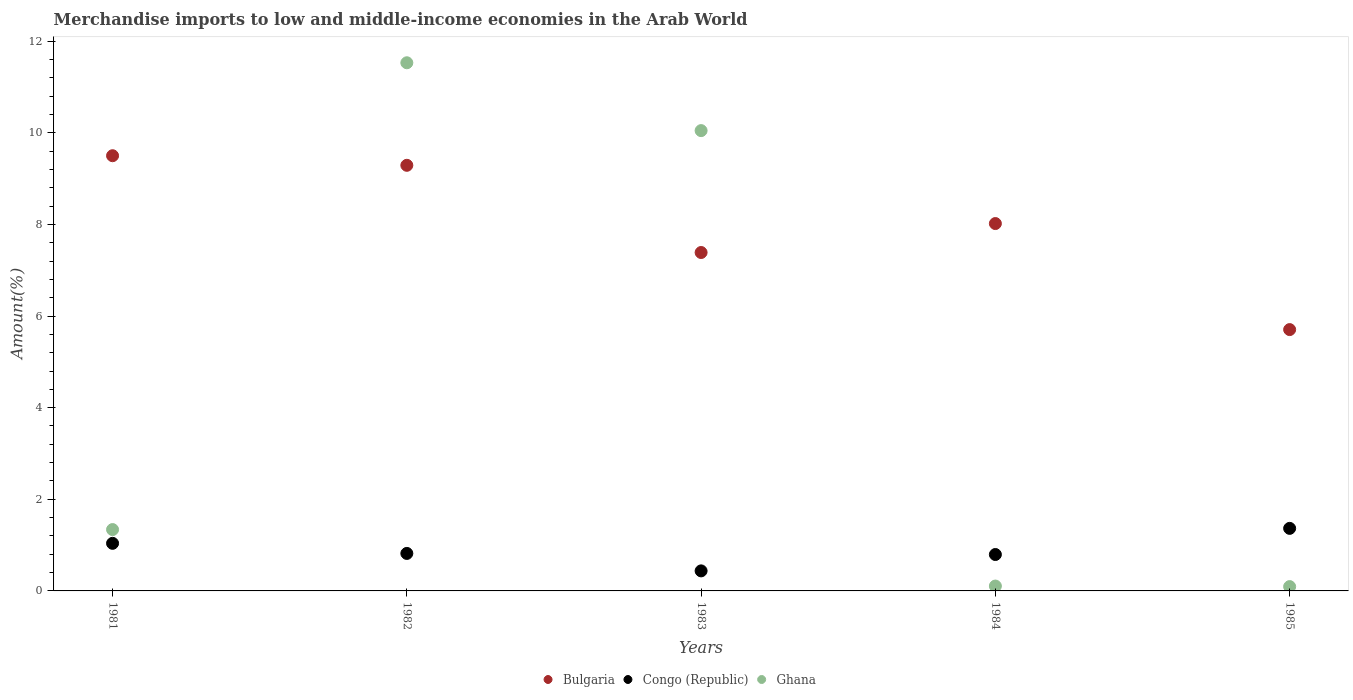How many different coloured dotlines are there?
Your response must be concise. 3. What is the percentage of amount earned from merchandise imports in Ghana in 1981?
Provide a succinct answer. 1.34. Across all years, what is the maximum percentage of amount earned from merchandise imports in Congo (Republic)?
Keep it short and to the point. 1.37. Across all years, what is the minimum percentage of amount earned from merchandise imports in Ghana?
Offer a very short reply. 0.09. In which year was the percentage of amount earned from merchandise imports in Bulgaria maximum?
Ensure brevity in your answer.  1981. In which year was the percentage of amount earned from merchandise imports in Ghana minimum?
Your answer should be very brief. 1985. What is the total percentage of amount earned from merchandise imports in Ghana in the graph?
Your response must be concise. 23.12. What is the difference between the percentage of amount earned from merchandise imports in Bulgaria in 1983 and that in 1984?
Ensure brevity in your answer.  -0.63. What is the difference between the percentage of amount earned from merchandise imports in Ghana in 1984 and the percentage of amount earned from merchandise imports in Bulgaria in 1981?
Ensure brevity in your answer.  -9.39. What is the average percentage of amount earned from merchandise imports in Ghana per year?
Keep it short and to the point. 4.62. In the year 1983, what is the difference between the percentage of amount earned from merchandise imports in Ghana and percentage of amount earned from merchandise imports in Bulgaria?
Make the answer very short. 2.66. In how many years, is the percentage of amount earned from merchandise imports in Congo (Republic) greater than 7.6 %?
Your response must be concise. 0. What is the ratio of the percentage of amount earned from merchandise imports in Congo (Republic) in 1982 to that in 1983?
Provide a short and direct response. 1.87. Is the percentage of amount earned from merchandise imports in Bulgaria in 1982 less than that in 1983?
Make the answer very short. No. What is the difference between the highest and the second highest percentage of amount earned from merchandise imports in Bulgaria?
Provide a succinct answer. 0.21. What is the difference between the highest and the lowest percentage of amount earned from merchandise imports in Ghana?
Ensure brevity in your answer.  11.43. Is the sum of the percentage of amount earned from merchandise imports in Bulgaria in 1981 and 1983 greater than the maximum percentage of amount earned from merchandise imports in Congo (Republic) across all years?
Your answer should be compact. Yes. Is the percentage of amount earned from merchandise imports in Bulgaria strictly greater than the percentage of amount earned from merchandise imports in Congo (Republic) over the years?
Make the answer very short. Yes. Is the percentage of amount earned from merchandise imports in Ghana strictly less than the percentage of amount earned from merchandise imports in Bulgaria over the years?
Your answer should be compact. No. How many years are there in the graph?
Keep it short and to the point. 5. Does the graph contain any zero values?
Make the answer very short. No. Does the graph contain grids?
Make the answer very short. No. How many legend labels are there?
Give a very brief answer. 3. How are the legend labels stacked?
Offer a very short reply. Horizontal. What is the title of the graph?
Provide a short and direct response. Merchandise imports to low and middle-income economies in the Arab World. What is the label or title of the Y-axis?
Offer a very short reply. Amount(%). What is the Amount(%) of Bulgaria in 1981?
Your answer should be very brief. 9.5. What is the Amount(%) of Congo (Republic) in 1981?
Provide a short and direct response. 1.04. What is the Amount(%) of Ghana in 1981?
Make the answer very short. 1.34. What is the Amount(%) in Bulgaria in 1982?
Make the answer very short. 9.29. What is the Amount(%) in Congo (Republic) in 1982?
Your response must be concise. 0.82. What is the Amount(%) in Ghana in 1982?
Ensure brevity in your answer.  11.53. What is the Amount(%) of Bulgaria in 1983?
Your answer should be very brief. 7.39. What is the Amount(%) in Congo (Republic) in 1983?
Offer a terse response. 0.44. What is the Amount(%) of Ghana in 1983?
Ensure brevity in your answer.  10.05. What is the Amount(%) in Bulgaria in 1984?
Your answer should be very brief. 8.02. What is the Amount(%) of Congo (Republic) in 1984?
Your answer should be compact. 0.79. What is the Amount(%) in Ghana in 1984?
Your answer should be compact. 0.11. What is the Amount(%) of Bulgaria in 1985?
Keep it short and to the point. 5.7. What is the Amount(%) of Congo (Republic) in 1985?
Provide a short and direct response. 1.37. What is the Amount(%) of Ghana in 1985?
Offer a terse response. 0.09. Across all years, what is the maximum Amount(%) of Bulgaria?
Your answer should be very brief. 9.5. Across all years, what is the maximum Amount(%) in Congo (Republic)?
Keep it short and to the point. 1.37. Across all years, what is the maximum Amount(%) in Ghana?
Your response must be concise. 11.53. Across all years, what is the minimum Amount(%) of Bulgaria?
Your answer should be very brief. 5.7. Across all years, what is the minimum Amount(%) of Congo (Republic)?
Make the answer very short. 0.44. Across all years, what is the minimum Amount(%) in Ghana?
Give a very brief answer. 0.09. What is the total Amount(%) in Bulgaria in the graph?
Your response must be concise. 39.9. What is the total Amount(%) of Congo (Republic) in the graph?
Offer a terse response. 4.46. What is the total Amount(%) of Ghana in the graph?
Make the answer very short. 23.12. What is the difference between the Amount(%) of Bulgaria in 1981 and that in 1982?
Provide a succinct answer. 0.21. What is the difference between the Amount(%) of Congo (Republic) in 1981 and that in 1982?
Give a very brief answer. 0.22. What is the difference between the Amount(%) of Ghana in 1981 and that in 1982?
Offer a very short reply. -10.19. What is the difference between the Amount(%) of Bulgaria in 1981 and that in 1983?
Keep it short and to the point. 2.11. What is the difference between the Amount(%) in Congo (Republic) in 1981 and that in 1983?
Provide a short and direct response. 0.6. What is the difference between the Amount(%) of Ghana in 1981 and that in 1983?
Provide a succinct answer. -8.71. What is the difference between the Amount(%) of Bulgaria in 1981 and that in 1984?
Keep it short and to the point. 1.48. What is the difference between the Amount(%) in Congo (Republic) in 1981 and that in 1984?
Provide a succinct answer. 0.24. What is the difference between the Amount(%) of Ghana in 1981 and that in 1984?
Offer a terse response. 1.23. What is the difference between the Amount(%) of Bulgaria in 1981 and that in 1985?
Ensure brevity in your answer.  3.8. What is the difference between the Amount(%) of Congo (Republic) in 1981 and that in 1985?
Offer a very short reply. -0.33. What is the difference between the Amount(%) of Ghana in 1981 and that in 1985?
Your answer should be compact. 1.24. What is the difference between the Amount(%) of Bulgaria in 1982 and that in 1983?
Your response must be concise. 1.9. What is the difference between the Amount(%) of Congo (Republic) in 1982 and that in 1983?
Provide a succinct answer. 0.38. What is the difference between the Amount(%) in Ghana in 1982 and that in 1983?
Offer a terse response. 1.48. What is the difference between the Amount(%) of Bulgaria in 1982 and that in 1984?
Your answer should be very brief. 1.27. What is the difference between the Amount(%) of Congo (Republic) in 1982 and that in 1984?
Your answer should be compact. 0.02. What is the difference between the Amount(%) in Ghana in 1982 and that in 1984?
Provide a succinct answer. 11.42. What is the difference between the Amount(%) of Bulgaria in 1982 and that in 1985?
Make the answer very short. 3.59. What is the difference between the Amount(%) in Congo (Republic) in 1982 and that in 1985?
Your response must be concise. -0.55. What is the difference between the Amount(%) in Ghana in 1982 and that in 1985?
Your answer should be very brief. 11.43. What is the difference between the Amount(%) in Bulgaria in 1983 and that in 1984?
Ensure brevity in your answer.  -0.63. What is the difference between the Amount(%) of Congo (Republic) in 1983 and that in 1984?
Keep it short and to the point. -0.36. What is the difference between the Amount(%) of Ghana in 1983 and that in 1984?
Keep it short and to the point. 9.94. What is the difference between the Amount(%) in Bulgaria in 1983 and that in 1985?
Give a very brief answer. 1.68. What is the difference between the Amount(%) in Congo (Republic) in 1983 and that in 1985?
Ensure brevity in your answer.  -0.93. What is the difference between the Amount(%) in Ghana in 1983 and that in 1985?
Make the answer very short. 9.95. What is the difference between the Amount(%) of Bulgaria in 1984 and that in 1985?
Your answer should be compact. 2.31. What is the difference between the Amount(%) in Congo (Republic) in 1984 and that in 1985?
Your answer should be very brief. -0.57. What is the difference between the Amount(%) of Ghana in 1984 and that in 1985?
Give a very brief answer. 0.01. What is the difference between the Amount(%) of Bulgaria in 1981 and the Amount(%) of Congo (Republic) in 1982?
Keep it short and to the point. 8.68. What is the difference between the Amount(%) in Bulgaria in 1981 and the Amount(%) in Ghana in 1982?
Offer a very short reply. -2.03. What is the difference between the Amount(%) of Congo (Republic) in 1981 and the Amount(%) of Ghana in 1982?
Your answer should be compact. -10.49. What is the difference between the Amount(%) in Bulgaria in 1981 and the Amount(%) in Congo (Republic) in 1983?
Ensure brevity in your answer.  9.06. What is the difference between the Amount(%) of Bulgaria in 1981 and the Amount(%) of Ghana in 1983?
Give a very brief answer. -0.55. What is the difference between the Amount(%) of Congo (Republic) in 1981 and the Amount(%) of Ghana in 1983?
Make the answer very short. -9.01. What is the difference between the Amount(%) in Bulgaria in 1981 and the Amount(%) in Congo (Republic) in 1984?
Provide a succinct answer. 8.7. What is the difference between the Amount(%) in Bulgaria in 1981 and the Amount(%) in Ghana in 1984?
Give a very brief answer. 9.39. What is the difference between the Amount(%) of Congo (Republic) in 1981 and the Amount(%) of Ghana in 1984?
Ensure brevity in your answer.  0.93. What is the difference between the Amount(%) in Bulgaria in 1981 and the Amount(%) in Congo (Republic) in 1985?
Give a very brief answer. 8.13. What is the difference between the Amount(%) in Bulgaria in 1981 and the Amount(%) in Ghana in 1985?
Ensure brevity in your answer.  9.41. What is the difference between the Amount(%) of Congo (Republic) in 1981 and the Amount(%) of Ghana in 1985?
Your response must be concise. 0.94. What is the difference between the Amount(%) in Bulgaria in 1982 and the Amount(%) in Congo (Republic) in 1983?
Make the answer very short. 8.85. What is the difference between the Amount(%) in Bulgaria in 1982 and the Amount(%) in Ghana in 1983?
Your answer should be compact. -0.76. What is the difference between the Amount(%) of Congo (Republic) in 1982 and the Amount(%) of Ghana in 1983?
Your response must be concise. -9.23. What is the difference between the Amount(%) in Bulgaria in 1982 and the Amount(%) in Congo (Republic) in 1984?
Your answer should be compact. 8.5. What is the difference between the Amount(%) in Bulgaria in 1982 and the Amount(%) in Ghana in 1984?
Ensure brevity in your answer.  9.18. What is the difference between the Amount(%) of Congo (Republic) in 1982 and the Amount(%) of Ghana in 1984?
Your response must be concise. 0.71. What is the difference between the Amount(%) of Bulgaria in 1982 and the Amount(%) of Congo (Republic) in 1985?
Ensure brevity in your answer.  7.92. What is the difference between the Amount(%) in Bulgaria in 1982 and the Amount(%) in Ghana in 1985?
Your response must be concise. 9.2. What is the difference between the Amount(%) of Congo (Republic) in 1982 and the Amount(%) of Ghana in 1985?
Your answer should be compact. 0.72. What is the difference between the Amount(%) of Bulgaria in 1983 and the Amount(%) of Congo (Republic) in 1984?
Offer a very short reply. 6.59. What is the difference between the Amount(%) in Bulgaria in 1983 and the Amount(%) in Ghana in 1984?
Give a very brief answer. 7.28. What is the difference between the Amount(%) in Congo (Republic) in 1983 and the Amount(%) in Ghana in 1984?
Provide a short and direct response. 0.33. What is the difference between the Amount(%) of Bulgaria in 1983 and the Amount(%) of Congo (Republic) in 1985?
Give a very brief answer. 6.02. What is the difference between the Amount(%) in Bulgaria in 1983 and the Amount(%) in Ghana in 1985?
Make the answer very short. 7.29. What is the difference between the Amount(%) in Congo (Republic) in 1983 and the Amount(%) in Ghana in 1985?
Your response must be concise. 0.34. What is the difference between the Amount(%) in Bulgaria in 1984 and the Amount(%) in Congo (Republic) in 1985?
Your response must be concise. 6.65. What is the difference between the Amount(%) of Bulgaria in 1984 and the Amount(%) of Ghana in 1985?
Provide a succinct answer. 7.92. What is the difference between the Amount(%) in Congo (Republic) in 1984 and the Amount(%) in Ghana in 1985?
Your answer should be very brief. 0.7. What is the average Amount(%) in Bulgaria per year?
Offer a terse response. 7.98. What is the average Amount(%) in Congo (Republic) per year?
Offer a very short reply. 0.89. What is the average Amount(%) of Ghana per year?
Keep it short and to the point. 4.62. In the year 1981, what is the difference between the Amount(%) of Bulgaria and Amount(%) of Congo (Republic)?
Your answer should be compact. 8.46. In the year 1981, what is the difference between the Amount(%) in Bulgaria and Amount(%) in Ghana?
Your answer should be very brief. 8.16. In the year 1981, what is the difference between the Amount(%) of Congo (Republic) and Amount(%) of Ghana?
Ensure brevity in your answer.  -0.3. In the year 1982, what is the difference between the Amount(%) in Bulgaria and Amount(%) in Congo (Republic)?
Your answer should be very brief. 8.47. In the year 1982, what is the difference between the Amount(%) in Bulgaria and Amount(%) in Ghana?
Offer a very short reply. -2.24. In the year 1982, what is the difference between the Amount(%) of Congo (Republic) and Amount(%) of Ghana?
Offer a terse response. -10.71. In the year 1983, what is the difference between the Amount(%) of Bulgaria and Amount(%) of Congo (Republic)?
Your answer should be very brief. 6.95. In the year 1983, what is the difference between the Amount(%) of Bulgaria and Amount(%) of Ghana?
Your response must be concise. -2.66. In the year 1983, what is the difference between the Amount(%) in Congo (Republic) and Amount(%) in Ghana?
Your answer should be compact. -9.61. In the year 1984, what is the difference between the Amount(%) of Bulgaria and Amount(%) of Congo (Republic)?
Ensure brevity in your answer.  7.22. In the year 1984, what is the difference between the Amount(%) in Bulgaria and Amount(%) in Ghana?
Keep it short and to the point. 7.91. In the year 1984, what is the difference between the Amount(%) in Congo (Republic) and Amount(%) in Ghana?
Make the answer very short. 0.69. In the year 1985, what is the difference between the Amount(%) in Bulgaria and Amount(%) in Congo (Republic)?
Keep it short and to the point. 4.34. In the year 1985, what is the difference between the Amount(%) in Bulgaria and Amount(%) in Ghana?
Offer a terse response. 5.61. In the year 1985, what is the difference between the Amount(%) of Congo (Republic) and Amount(%) of Ghana?
Offer a terse response. 1.27. What is the ratio of the Amount(%) of Bulgaria in 1981 to that in 1982?
Make the answer very short. 1.02. What is the ratio of the Amount(%) of Congo (Republic) in 1981 to that in 1982?
Provide a succinct answer. 1.27. What is the ratio of the Amount(%) of Ghana in 1981 to that in 1982?
Ensure brevity in your answer.  0.12. What is the ratio of the Amount(%) in Bulgaria in 1981 to that in 1983?
Make the answer very short. 1.29. What is the ratio of the Amount(%) of Congo (Republic) in 1981 to that in 1983?
Your response must be concise. 2.37. What is the ratio of the Amount(%) of Ghana in 1981 to that in 1983?
Provide a short and direct response. 0.13. What is the ratio of the Amount(%) of Bulgaria in 1981 to that in 1984?
Your answer should be compact. 1.18. What is the ratio of the Amount(%) of Congo (Republic) in 1981 to that in 1984?
Your response must be concise. 1.31. What is the ratio of the Amount(%) in Ghana in 1981 to that in 1984?
Give a very brief answer. 12.59. What is the ratio of the Amount(%) of Bulgaria in 1981 to that in 1985?
Offer a terse response. 1.67. What is the ratio of the Amount(%) in Congo (Republic) in 1981 to that in 1985?
Provide a succinct answer. 0.76. What is the ratio of the Amount(%) of Ghana in 1981 to that in 1985?
Provide a succinct answer. 14.21. What is the ratio of the Amount(%) in Bulgaria in 1982 to that in 1983?
Your response must be concise. 1.26. What is the ratio of the Amount(%) in Congo (Republic) in 1982 to that in 1983?
Ensure brevity in your answer.  1.87. What is the ratio of the Amount(%) of Ghana in 1982 to that in 1983?
Ensure brevity in your answer.  1.15. What is the ratio of the Amount(%) in Bulgaria in 1982 to that in 1984?
Make the answer very short. 1.16. What is the ratio of the Amount(%) of Congo (Republic) in 1982 to that in 1984?
Give a very brief answer. 1.03. What is the ratio of the Amount(%) of Ghana in 1982 to that in 1984?
Keep it short and to the point. 108.36. What is the ratio of the Amount(%) of Bulgaria in 1982 to that in 1985?
Provide a short and direct response. 1.63. What is the ratio of the Amount(%) in Congo (Republic) in 1982 to that in 1985?
Keep it short and to the point. 0.6. What is the ratio of the Amount(%) in Ghana in 1982 to that in 1985?
Provide a succinct answer. 122.31. What is the ratio of the Amount(%) in Bulgaria in 1983 to that in 1984?
Make the answer very short. 0.92. What is the ratio of the Amount(%) of Congo (Republic) in 1983 to that in 1984?
Offer a very short reply. 0.55. What is the ratio of the Amount(%) of Ghana in 1983 to that in 1984?
Keep it short and to the point. 94.44. What is the ratio of the Amount(%) in Bulgaria in 1983 to that in 1985?
Provide a succinct answer. 1.29. What is the ratio of the Amount(%) of Congo (Republic) in 1983 to that in 1985?
Give a very brief answer. 0.32. What is the ratio of the Amount(%) of Ghana in 1983 to that in 1985?
Give a very brief answer. 106.6. What is the ratio of the Amount(%) of Bulgaria in 1984 to that in 1985?
Give a very brief answer. 1.41. What is the ratio of the Amount(%) of Congo (Republic) in 1984 to that in 1985?
Keep it short and to the point. 0.58. What is the ratio of the Amount(%) of Ghana in 1984 to that in 1985?
Your response must be concise. 1.13. What is the difference between the highest and the second highest Amount(%) of Bulgaria?
Provide a short and direct response. 0.21. What is the difference between the highest and the second highest Amount(%) in Congo (Republic)?
Keep it short and to the point. 0.33. What is the difference between the highest and the second highest Amount(%) in Ghana?
Provide a succinct answer. 1.48. What is the difference between the highest and the lowest Amount(%) in Bulgaria?
Provide a short and direct response. 3.8. What is the difference between the highest and the lowest Amount(%) of Congo (Republic)?
Offer a terse response. 0.93. What is the difference between the highest and the lowest Amount(%) of Ghana?
Ensure brevity in your answer.  11.43. 